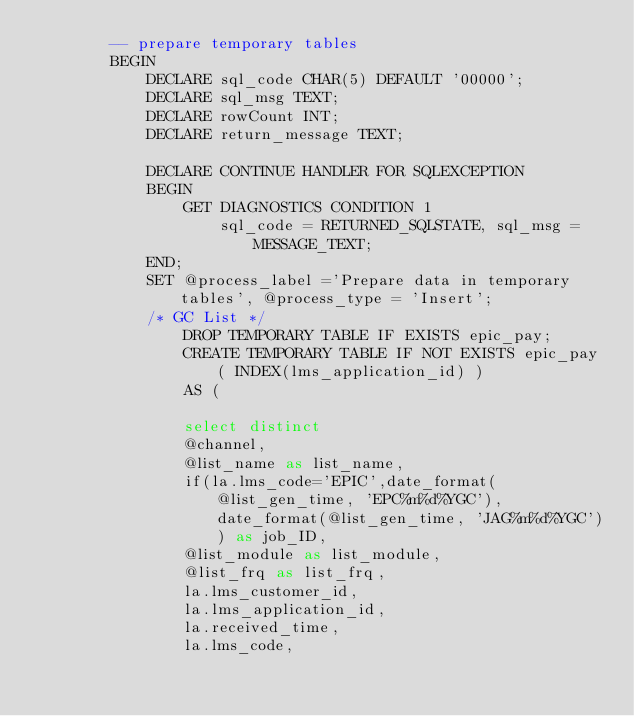Convert code to text. <code><loc_0><loc_0><loc_500><loc_500><_SQL_>		-- prepare temporary tables 
		BEGIN
			DECLARE sql_code CHAR(5) DEFAULT '00000';
			DECLARE sql_msg TEXT;
			DECLARE rowCount INT;
			DECLARE return_message TEXT;

			DECLARE CONTINUE HANDLER FOR SQLEXCEPTION
			BEGIN
				GET DIAGNOSTICS CONDITION 1
					sql_code = RETURNED_SQLSTATE, sql_msg = MESSAGE_TEXT;
			END;
			SET @process_label ='Prepare data in temporary tables', @process_type = 'Insert';	
			/* GC List */
				DROP TEMPORARY TABLE IF EXISTS epic_pay;
				CREATE TEMPORARY TABLE IF NOT EXISTS epic_pay ( INDEX(lms_application_id) ) 
				AS (

				select distinct
				@channel,
				@list_name as list_name,
				if(la.lms_code='EPIC',date_format(@list_gen_time, 'EPC%m%d%YGC'), date_format(@list_gen_time, 'JAG%m%d%YGC')) as job_ID,
				@list_module as list_module,
				@list_frq as list_frq,
				la.lms_customer_id, 
				la.lms_application_id,
				la.received_time,
				la.lms_code, </code> 